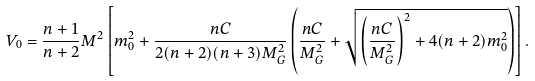Convert formula to latex. <formula><loc_0><loc_0><loc_500><loc_500>V _ { 0 } = \frac { n + 1 } { n + 2 } M ^ { 2 } \left [ m _ { 0 } ^ { 2 } + \frac { n C } { 2 ( n + 2 ) ( n + 3 ) M _ { G } ^ { 2 } } \left ( \frac { n C } { M _ { G } ^ { 2 } } + \sqrt { \left ( \frac { n C } { M _ { G } ^ { 2 } } \right ) ^ { 2 } + 4 ( n + 2 ) m _ { 0 } ^ { 2 } } \right ) \right ] .</formula> 